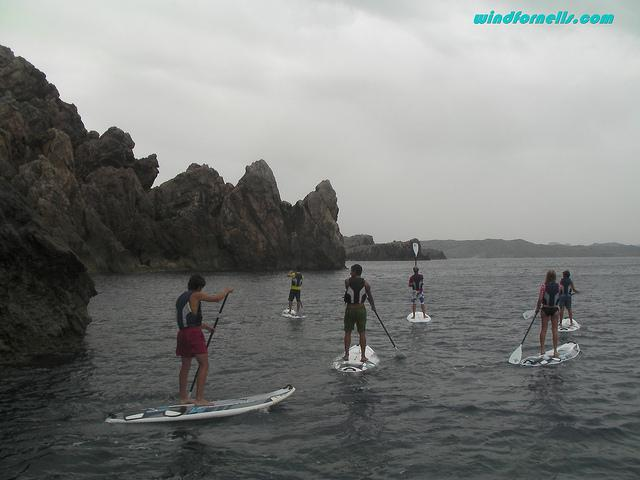What is required for this activity?

Choices:
A) wind
B) ice
C) water
D) snow water 